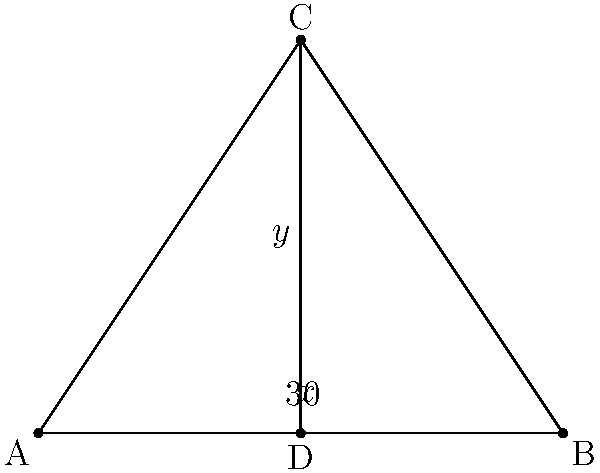In a minimally invasive surgical procedure, the optimal incision placement is crucial. Consider the diagram above, where triangle ABC represents the surgical site, and CD is the proposed incision line. Given that angle ACD is 30°, determine the value of angle BCD (represented by x°) and angle ACI (represented by y°). Let's approach this step-by-step:

1) In triangle ACD:
   - We know that angle ACD = 30°
   - AD is the base of the triangle, so angles CAD and CDA are equal
   - Let's call each of these angles z°
   - In a triangle, the sum of all angles is 180°
   So, $30° + z° + z° = 180°$
   $30° + 2z° = 180°$
   $2z° = 150°$
   $z° = 75°$

2) Now, for angle BCD (x°):
   - We know that a straight line forms a 180° angle
   - So, $x° + 30° = 180°$
   $x° = 150°$

3) For angle ACI (y°):
   - In triangle ABC, we now know two angles: CAB (75°) and ABC (75°)
   - The sum of angles in a triangle is 180°
   So, $75° + 75° + y° = 180°$
   $150° + y° = 180°$
   $y° = 30°$

Therefore, angle BCD (x°) = 150° and angle ACI (y°) = 30°.
Answer: $x = 150°$, $y = 30°$ 